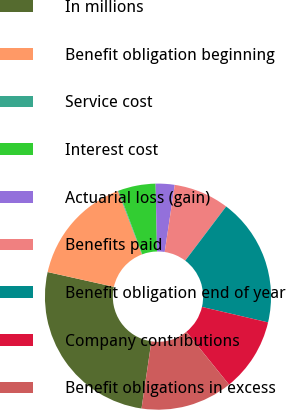<chart> <loc_0><loc_0><loc_500><loc_500><pie_chart><fcel>In millions<fcel>Benefit obligation beginning<fcel>Service cost<fcel>Interest cost<fcel>Actuarial loss (gain)<fcel>Benefits paid<fcel>Benefit obligation end of year<fcel>Company contributions<fcel>Benefit obligations in excess<nl><fcel>26.17%<fcel>15.74%<fcel>0.11%<fcel>5.32%<fcel>2.71%<fcel>7.93%<fcel>18.35%<fcel>10.53%<fcel>13.14%<nl></chart> 